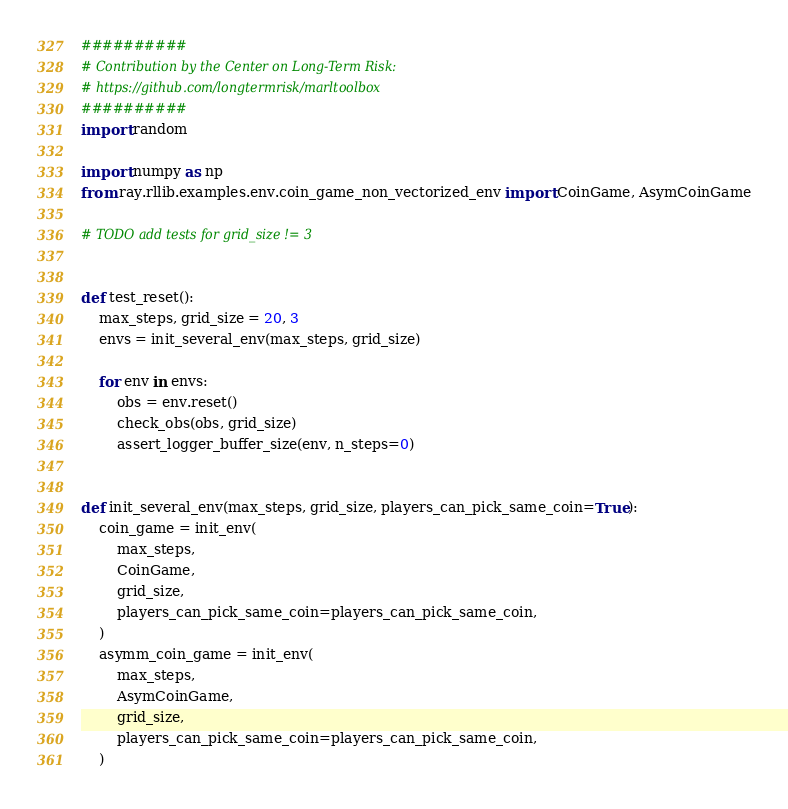Convert code to text. <code><loc_0><loc_0><loc_500><loc_500><_Python_>##########
# Contribution by the Center on Long-Term Risk:
# https://github.com/longtermrisk/marltoolbox
##########
import random

import numpy as np
from ray.rllib.examples.env.coin_game_non_vectorized_env import CoinGame, AsymCoinGame

# TODO add tests for grid_size != 3


def test_reset():
    max_steps, grid_size = 20, 3
    envs = init_several_env(max_steps, grid_size)

    for env in envs:
        obs = env.reset()
        check_obs(obs, grid_size)
        assert_logger_buffer_size(env, n_steps=0)


def init_several_env(max_steps, grid_size, players_can_pick_same_coin=True):
    coin_game = init_env(
        max_steps,
        CoinGame,
        grid_size,
        players_can_pick_same_coin=players_can_pick_same_coin,
    )
    asymm_coin_game = init_env(
        max_steps,
        AsymCoinGame,
        grid_size,
        players_can_pick_same_coin=players_can_pick_same_coin,
    )</code> 